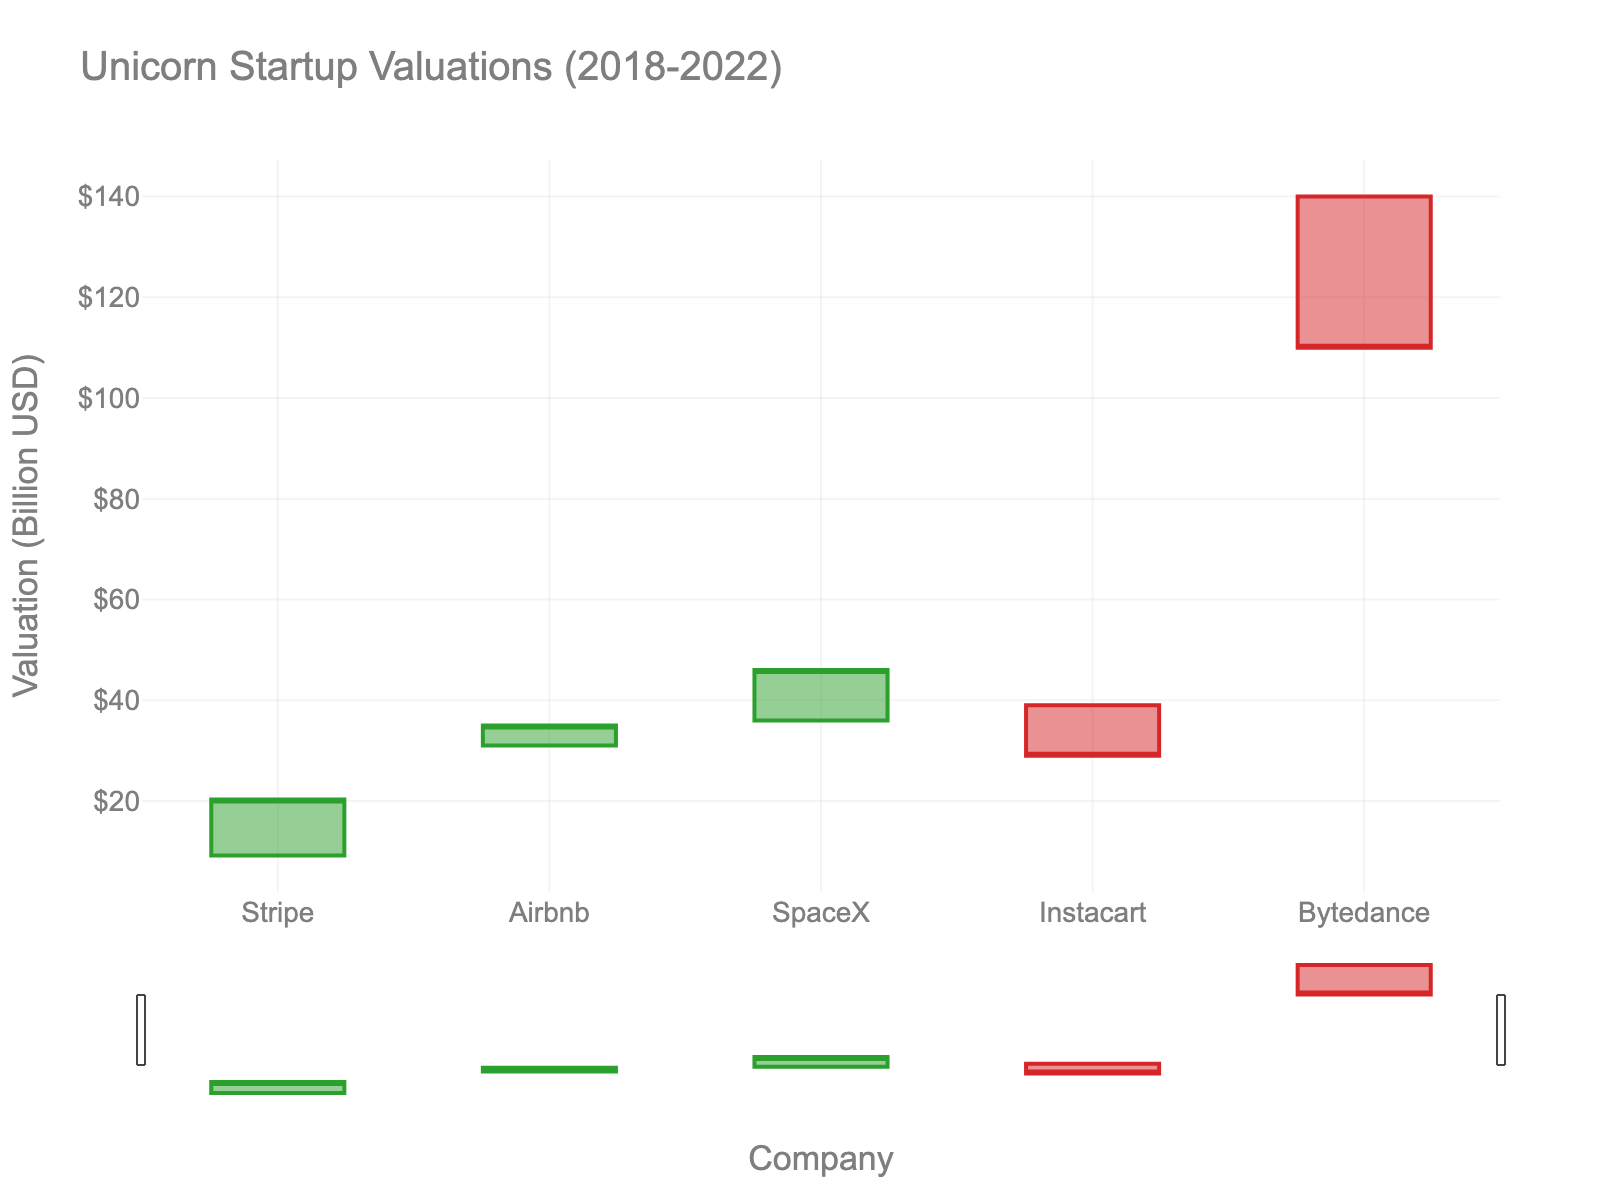How many companies are represented in the chart? Count the number of unique companies listed on the x-axis.
Answer: 5 Which year shows the highest closing valuation? Look for the highest closing value among the years on the y-axis.
Answer: 2022 What is the range of valuations for SpaceX in 2020? Subtract the lowest value (Low) from the highest value (High) for SpaceX in 2020.
Answer: 10.0 billion USD Which company has the lowest final closing valuation? Check the closing valuations on the y-axis and identify the smallest one.
Answer: Bytedance How does Instacart's high valuation in 2021 compare to its low valuation? Note the high and low values for Instacart in 2021 and compare them.
Answer: High valuation is the same as the low valuation Which year experienced the greatest increase in valuation from open to close? Find the difference between open and close values for each year and identify the largest positive difference.
Answer: 2018 Rank the companies by their closing valuations in descending order. List the companies and their closing valuations, then order them from highest to lowest.
Answer: Bytedance, SpaceX, Airbnb, Stripe, Instacart What is the total sum of the opening valuations for all companies? Add the open values of all companies shown in the chart.
Answer: 255.2 billion USD Identify and compare the companies that have both their high and low valuations equal in a given year. Look for companies where the high and low valuations are the same and compare any similarities.
Answer: Stripe, Airbnb, SpaceX 